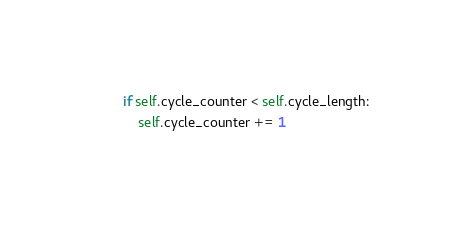<code> <loc_0><loc_0><loc_500><loc_500><_Python_>        if self.cycle_counter < self.cycle_length:
            self.cycle_counter += 1</code> 